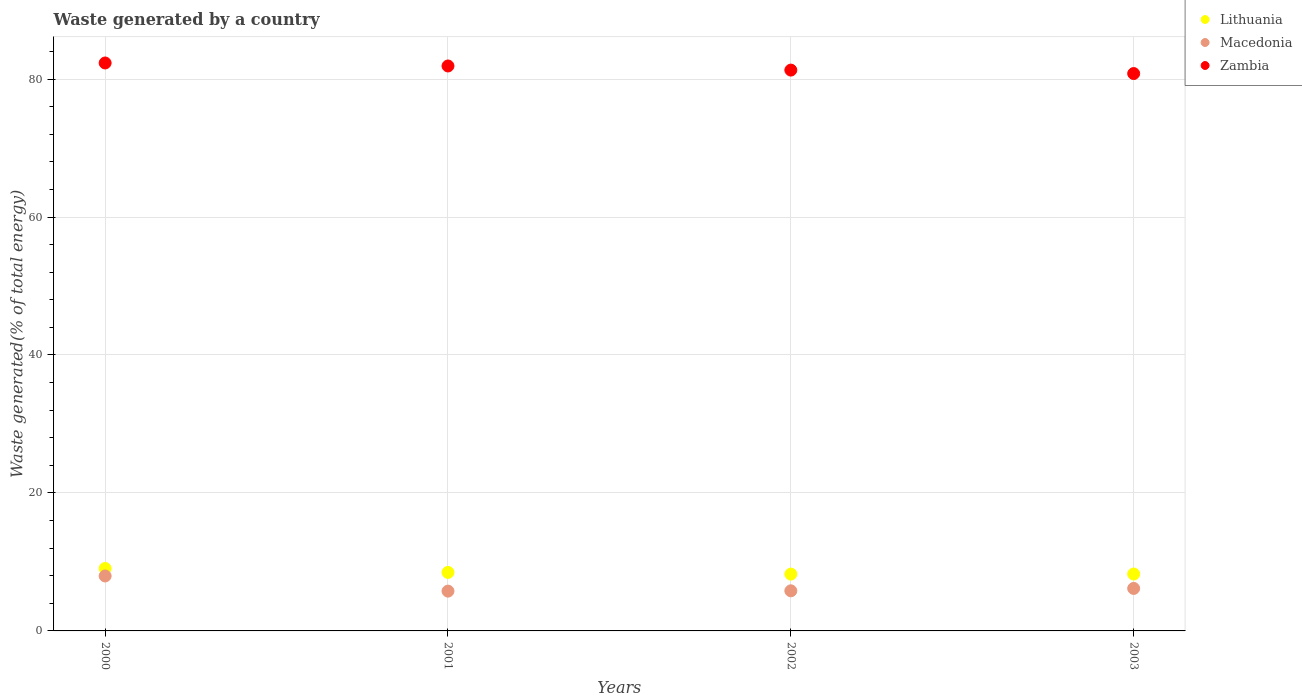Is the number of dotlines equal to the number of legend labels?
Keep it short and to the point. Yes. What is the total waste generated in Lithuania in 2000?
Your response must be concise. 9.05. Across all years, what is the maximum total waste generated in Lithuania?
Your answer should be compact. 9.05. Across all years, what is the minimum total waste generated in Lithuania?
Your answer should be compact. 8.23. In which year was the total waste generated in Lithuania maximum?
Your answer should be very brief. 2000. In which year was the total waste generated in Macedonia minimum?
Ensure brevity in your answer.  2001. What is the total total waste generated in Zambia in the graph?
Keep it short and to the point. 326.32. What is the difference between the total waste generated in Lithuania in 2000 and that in 2002?
Provide a short and direct response. 0.81. What is the difference between the total waste generated in Macedonia in 2001 and the total waste generated in Zambia in 2000?
Ensure brevity in your answer.  -76.56. What is the average total waste generated in Lithuania per year?
Ensure brevity in your answer.  8.5. In the year 2000, what is the difference between the total waste generated in Zambia and total waste generated in Macedonia?
Provide a succinct answer. 74.36. In how many years, is the total waste generated in Macedonia greater than 20 %?
Keep it short and to the point. 0. What is the ratio of the total waste generated in Lithuania in 2000 to that in 2001?
Keep it short and to the point. 1.07. What is the difference between the highest and the second highest total waste generated in Lithuania?
Your answer should be very brief. 0.57. What is the difference between the highest and the lowest total waste generated in Macedonia?
Provide a succinct answer. 2.2. How many years are there in the graph?
Ensure brevity in your answer.  4. Where does the legend appear in the graph?
Your response must be concise. Top right. How many legend labels are there?
Your response must be concise. 3. How are the legend labels stacked?
Keep it short and to the point. Vertical. What is the title of the graph?
Your answer should be very brief. Waste generated by a country. Does "Namibia" appear as one of the legend labels in the graph?
Your response must be concise. No. What is the label or title of the Y-axis?
Provide a succinct answer. Waste generated(% of total energy). What is the Waste generated(% of total energy) of Lithuania in 2000?
Your response must be concise. 9.05. What is the Waste generated(% of total energy) of Macedonia in 2000?
Offer a terse response. 7.96. What is the Waste generated(% of total energy) in Zambia in 2000?
Your answer should be compact. 82.33. What is the Waste generated(% of total energy) in Lithuania in 2001?
Make the answer very short. 8.48. What is the Waste generated(% of total energy) of Macedonia in 2001?
Keep it short and to the point. 5.77. What is the Waste generated(% of total energy) in Zambia in 2001?
Provide a succinct answer. 81.89. What is the Waste generated(% of total energy) of Lithuania in 2002?
Your answer should be very brief. 8.23. What is the Waste generated(% of total energy) of Macedonia in 2002?
Keep it short and to the point. 5.81. What is the Waste generated(% of total energy) of Zambia in 2002?
Offer a very short reply. 81.3. What is the Waste generated(% of total energy) of Lithuania in 2003?
Make the answer very short. 8.25. What is the Waste generated(% of total energy) of Macedonia in 2003?
Give a very brief answer. 6.16. What is the Waste generated(% of total energy) of Zambia in 2003?
Ensure brevity in your answer.  80.8. Across all years, what is the maximum Waste generated(% of total energy) in Lithuania?
Make the answer very short. 9.05. Across all years, what is the maximum Waste generated(% of total energy) in Macedonia?
Offer a very short reply. 7.96. Across all years, what is the maximum Waste generated(% of total energy) in Zambia?
Provide a succinct answer. 82.33. Across all years, what is the minimum Waste generated(% of total energy) of Lithuania?
Your answer should be compact. 8.23. Across all years, what is the minimum Waste generated(% of total energy) of Macedonia?
Give a very brief answer. 5.77. Across all years, what is the minimum Waste generated(% of total energy) in Zambia?
Your answer should be very brief. 80.8. What is the total Waste generated(% of total energy) of Lithuania in the graph?
Offer a very short reply. 34.01. What is the total Waste generated(% of total energy) in Macedonia in the graph?
Offer a terse response. 25.7. What is the total Waste generated(% of total energy) of Zambia in the graph?
Offer a very short reply. 326.32. What is the difference between the Waste generated(% of total energy) of Lithuania in 2000 and that in 2001?
Your answer should be very brief. 0.57. What is the difference between the Waste generated(% of total energy) in Macedonia in 2000 and that in 2001?
Your response must be concise. 2.2. What is the difference between the Waste generated(% of total energy) of Zambia in 2000 and that in 2001?
Give a very brief answer. 0.43. What is the difference between the Waste generated(% of total energy) of Lithuania in 2000 and that in 2002?
Give a very brief answer. 0.81. What is the difference between the Waste generated(% of total energy) of Macedonia in 2000 and that in 2002?
Provide a short and direct response. 2.15. What is the difference between the Waste generated(% of total energy) in Zambia in 2000 and that in 2002?
Ensure brevity in your answer.  1.03. What is the difference between the Waste generated(% of total energy) in Lithuania in 2000 and that in 2003?
Your response must be concise. 0.8. What is the difference between the Waste generated(% of total energy) of Macedonia in 2000 and that in 2003?
Offer a terse response. 1.8. What is the difference between the Waste generated(% of total energy) in Zambia in 2000 and that in 2003?
Provide a short and direct response. 1.53. What is the difference between the Waste generated(% of total energy) in Lithuania in 2001 and that in 2002?
Offer a very short reply. 0.25. What is the difference between the Waste generated(% of total energy) of Macedonia in 2001 and that in 2002?
Offer a very short reply. -0.04. What is the difference between the Waste generated(% of total energy) of Zambia in 2001 and that in 2002?
Your answer should be very brief. 0.6. What is the difference between the Waste generated(% of total energy) of Lithuania in 2001 and that in 2003?
Your answer should be very brief. 0.24. What is the difference between the Waste generated(% of total energy) of Macedonia in 2001 and that in 2003?
Offer a terse response. -0.39. What is the difference between the Waste generated(% of total energy) of Zambia in 2001 and that in 2003?
Offer a very short reply. 1.1. What is the difference between the Waste generated(% of total energy) of Lithuania in 2002 and that in 2003?
Your answer should be very brief. -0.01. What is the difference between the Waste generated(% of total energy) in Macedonia in 2002 and that in 2003?
Your answer should be compact. -0.35. What is the difference between the Waste generated(% of total energy) of Zambia in 2002 and that in 2003?
Your answer should be very brief. 0.5. What is the difference between the Waste generated(% of total energy) in Lithuania in 2000 and the Waste generated(% of total energy) in Macedonia in 2001?
Offer a terse response. 3.28. What is the difference between the Waste generated(% of total energy) in Lithuania in 2000 and the Waste generated(% of total energy) in Zambia in 2001?
Ensure brevity in your answer.  -72.85. What is the difference between the Waste generated(% of total energy) in Macedonia in 2000 and the Waste generated(% of total energy) in Zambia in 2001?
Provide a short and direct response. -73.93. What is the difference between the Waste generated(% of total energy) of Lithuania in 2000 and the Waste generated(% of total energy) of Macedonia in 2002?
Make the answer very short. 3.24. What is the difference between the Waste generated(% of total energy) in Lithuania in 2000 and the Waste generated(% of total energy) in Zambia in 2002?
Offer a very short reply. -72.25. What is the difference between the Waste generated(% of total energy) of Macedonia in 2000 and the Waste generated(% of total energy) of Zambia in 2002?
Offer a terse response. -73.33. What is the difference between the Waste generated(% of total energy) in Lithuania in 2000 and the Waste generated(% of total energy) in Macedonia in 2003?
Keep it short and to the point. 2.89. What is the difference between the Waste generated(% of total energy) in Lithuania in 2000 and the Waste generated(% of total energy) in Zambia in 2003?
Your response must be concise. -71.75. What is the difference between the Waste generated(% of total energy) in Macedonia in 2000 and the Waste generated(% of total energy) in Zambia in 2003?
Provide a short and direct response. -72.83. What is the difference between the Waste generated(% of total energy) in Lithuania in 2001 and the Waste generated(% of total energy) in Macedonia in 2002?
Keep it short and to the point. 2.67. What is the difference between the Waste generated(% of total energy) in Lithuania in 2001 and the Waste generated(% of total energy) in Zambia in 2002?
Your answer should be compact. -72.81. What is the difference between the Waste generated(% of total energy) in Macedonia in 2001 and the Waste generated(% of total energy) in Zambia in 2002?
Keep it short and to the point. -75.53. What is the difference between the Waste generated(% of total energy) in Lithuania in 2001 and the Waste generated(% of total energy) in Macedonia in 2003?
Your response must be concise. 2.32. What is the difference between the Waste generated(% of total energy) of Lithuania in 2001 and the Waste generated(% of total energy) of Zambia in 2003?
Ensure brevity in your answer.  -72.31. What is the difference between the Waste generated(% of total energy) in Macedonia in 2001 and the Waste generated(% of total energy) in Zambia in 2003?
Your answer should be very brief. -75.03. What is the difference between the Waste generated(% of total energy) of Lithuania in 2002 and the Waste generated(% of total energy) of Macedonia in 2003?
Your answer should be compact. 2.08. What is the difference between the Waste generated(% of total energy) of Lithuania in 2002 and the Waste generated(% of total energy) of Zambia in 2003?
Provide a short and direct response. -72.56. What is the difference between the Waste generated(% of total energy) of Macedonia in 2002 and the Waste generated(% of total energy) of Zambia in 2003?
Give a very brief answer. -74.98. What is the average Waste generated(% of total energy) of Lithuania per year?
Your answer should be compact. 8.5. What is the average Waste generated(% of total energy) in Macedonia per year?
Provide a succinct answer. 6.43. What is the average Waste generated(% of total energy) of Zambia per year?
Your answer should be compact. 81.58. In the year 2000, what is the difference between the Waste generated(% of total energy) in Lithuania and Waste generated(% of total energy) in Macedonia?
Keep it short and to the point. 1.08. In the year 2000, what is the difference between the Waste generated(% of total energy) in Lithuania and Waste generated(% of total energy) in Zambia?
Provide a succinct answer. -73.28. In the year 2000, what is the difference between the Waste generated(% of total energy) of Macedonia and Waste generated(% of total energy) of Zambia?
Make the answer very short. -74.36. In the year 2001, what is the difference between the Waste generated(% of total energy) of Lithuania and Waste generated(% of total energy) of Macedonia?
Offer a very short reply. 2.71. In the year 2001, what is the difference between the Waste generated(% of total energy) in Lithuania and Waste generated(% of total energy) in Zambia?
Your answer should be very brief. -73.41. In the year 2001, what is the difference between the Waste generated(% of total energy) of Macedonia and Waste generated(% of total energy) of Zambia?
Give a very brief answer. -76.13. In the year 2002, what is the difference between the Waste generated(% of total energy) in Lithuania and Waste generated(% of total energy) in Macedonia?
Give a very brief answer. 2.42. In the year 2002, what is the difference between the Waste generated(% of total energy) of Lithuania and Waste generated(% of total energy) of Zambia?
Your answer should be very brief. -73.06. In the year 2002, what is the difference between the Waste generated(% of total energy) of Macedonia and Waste generated(% of total energy) of Zambia?
Provide a short and direct response. -75.48. In the year 2003, what is the difference between the Waste generated(% of total energy) of Lithuania and Waste generated(% of total energy) of Macedonia?
Offer a very short reply. 2.09. In the year 2003, what is the difference between the Waste generated(% of total energy) of Lithuania and Waste generated(% of total energy) of Zambia?
Your answer should be compact. -72.55. In the year 2003, what is the difference between the Waste generated(% of total energy) of Macedonia and Waste generated(% of total energy) of Zambia?
Offer a very short reply. -74.64. What is the ratio of the Waste generated(% of total energy) of Lithuania in 2000 to that in 2001?
Offer a very short reply. 1.07. What is the ratio of the Waste generated(% of total energy) in Macedonia in 2000 to that in 2001?
Your response must be concise. 1.38. What is the ratio of the Waste generated(% of total energy) of Zambia in 2000 to that in 2001?
Your response must be concise. 1.01. What is the ratio of the Waste generated(% of total energy) in Lithuania in 2000 to that in 2002?
Offer a terse response. 1.1. What is the ratio of the Waste generated(% of total energy) of Macedonia in 2000 to that in 2002?
Ensure brevity in your answer.  1.37. What is the ratio of the Waste generated(% of total energy) of Zambia in 2000 to that in 2002?
Keep it short and to the point. 1.01. What is the ratio of the Waste generated(% of total energy) in Lithuania in 2000 to that in 2003?
Your response must be concise. 1.1. What is the ratio of the Waste generated(% of total energy) in Macedonia in 2000 to that in 2003?
Your answer should be compact. 1.29. What is the ratio of the Waste generated(% of total energy) of Lithuania in 2001 to that in 2002?
Provide a short and direct response. 1.03. What is the ratio of the Waste generated(% of total energy) of Zambia in 2001 to that in 2002?
Offer a terse response. 1.01. What is the ratio of the Waste generated(% of total energy) of Lithuania in 2001 to that in 2003?
Your answer should be very brief. 1.03. What is the ratio of the Waste generated(% of total energy) in Macedonia in 2001 to that in 2003?
Provide a succinct answer. 0.94. What is the ratio of the Waste generated(% of total energy) of Zambia in 2001 to that in 2003?
Your answer should be very brief. 1.01. What is the ratio of the Waste generated(% of total energy) in Lithuania in 2002 to that in 2003?
Ensure brevity in your answer.  1. What is the ratio of the Waste generated(% of total energy) in Macedonia in 2002 to that in 2003?
Give a very brief answer. 0.94. What is the difference between the highest and the second highest Waste generated(% of total energy) of Lithuania?
Ensure brevity in your answer.  0.57. What is the difference between the highest and the second highest Waste generated(% of total energy) in Macedonia?
Provide a succinct answer. 1.8. What is the difference between the highest and the second highest Waste generated(% of total energy) in Zambia?
Ensure brevity in your answer.  0.43. What is the difference between the highest and the lowest Waste generated(% of total energy) in Lithuania?
Provide a succinct answer. 0.81. What is the difference between the highest and the lowest Waste generated(% of total energy) of Macedonia?
Give a very brief answer. 2.2. What is the difference between the highest and the lowest Waste generated(% of total energy) of Zambia?
Your answer should be very brief. 1.53. 